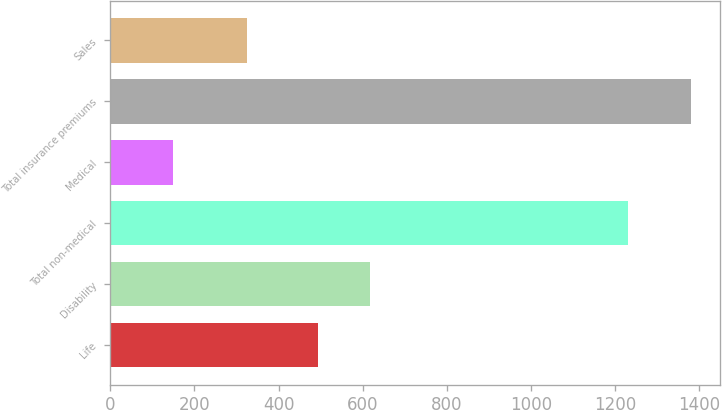Convert chart to OTSL. <chart><loc_0><loc_0><loc_500><loc_500><bar_chart><fcel>Life<fcel>Disability<fcel>Total non-medical<fcel>Medical<fcel>Total insurance premiums<fcel>Sales<nl><fcel>494<fcel>617.1<fcel>1231<fcel>149<fcel>1380<fcel>326<nl></chart> 